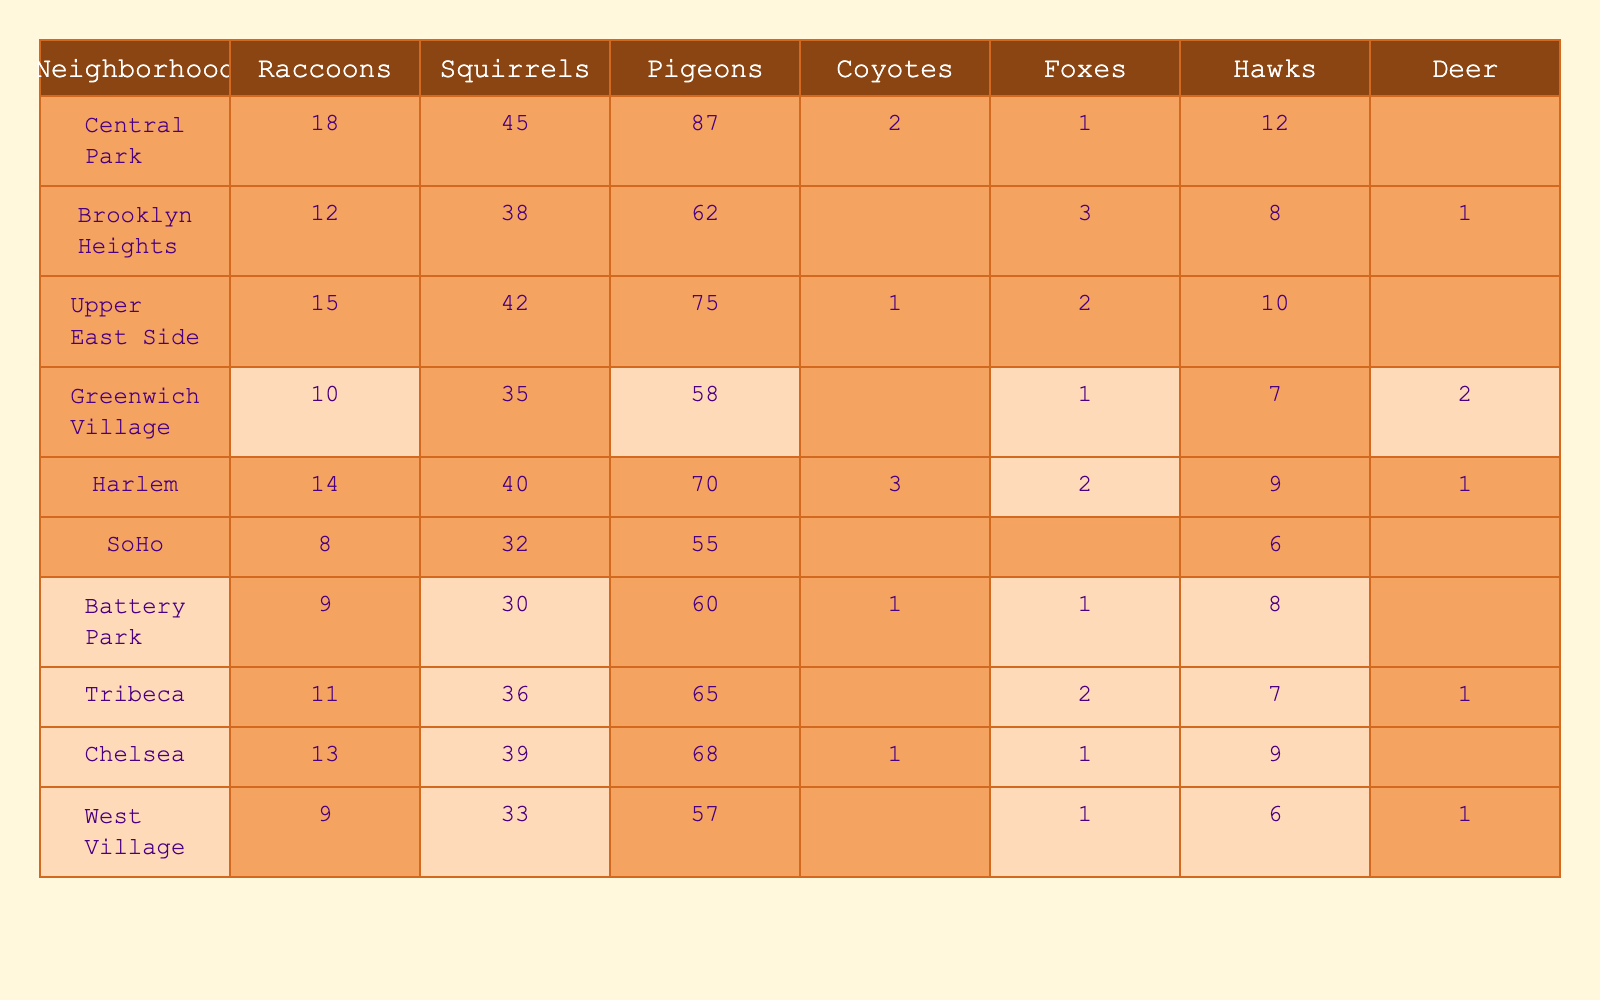What is the total number of raccoons sighted in Central Park? The table shows that Central Park has 18 raccoons.
Answer: 18 How many squirrels were sighted in the Upper East Side? According to the table, there were 42 squirrels sighted in the Upper East Side.
Answer: 42 Which neighborhood has the highest number of pigeons? By comparing the values in the table, Central Park has 87 pigeons, which is the highest.
Answer: Central Park Are there any sightings of deer in SoHo? The table shows that SoHo has 0 deer sighted, which confirms there were no deer sightings there.
Answer: No Which neighborhood has the most sightings of both raccoons and foxes combined? By adding the raccoon and fox counts, Central Park has 18 raccoons + 1 fox = 19, Brooklyn Heights has 12 + 3 = 15, and others are less. Hence, Central Park has the highest combined sightings.
Answer: Central Park What is the average number of hawks sighted across all neighborhoods? The total number of hawks is 12 + 8 + 10 + 1 + 2 + 0 + 1 + 2 + 9 + 6 = 51, and there are 10 neighborhoods, so the average is 51/10 = 5.1.
Answer: 5.1 How many neighborhoods reported sightings of coyotes? The table lists 5 neighborhoods with coyotes sighted: Central Park, Harlem, and others. Counting the entries shows 3 neighborhoods had sightings.
Answer: 3 Is there a neighborhood that recorded sightings for all types of wildlife? Checking the table, none of the neighborhoods have sightings for all species since all have zero for at least one type.
Answer: No What is the difference in the number of deer sighted between Greenwich Village and Harlem? Greenwich Village has 2 deer and Harlem has 1, so the difference is 2 - 1 = 1.
Answer: 1 Which neighborhood has the least sightings of pigeons? By examining the values, SoHo has the lowest count of pigeons with 55.
Answer: SoHo 